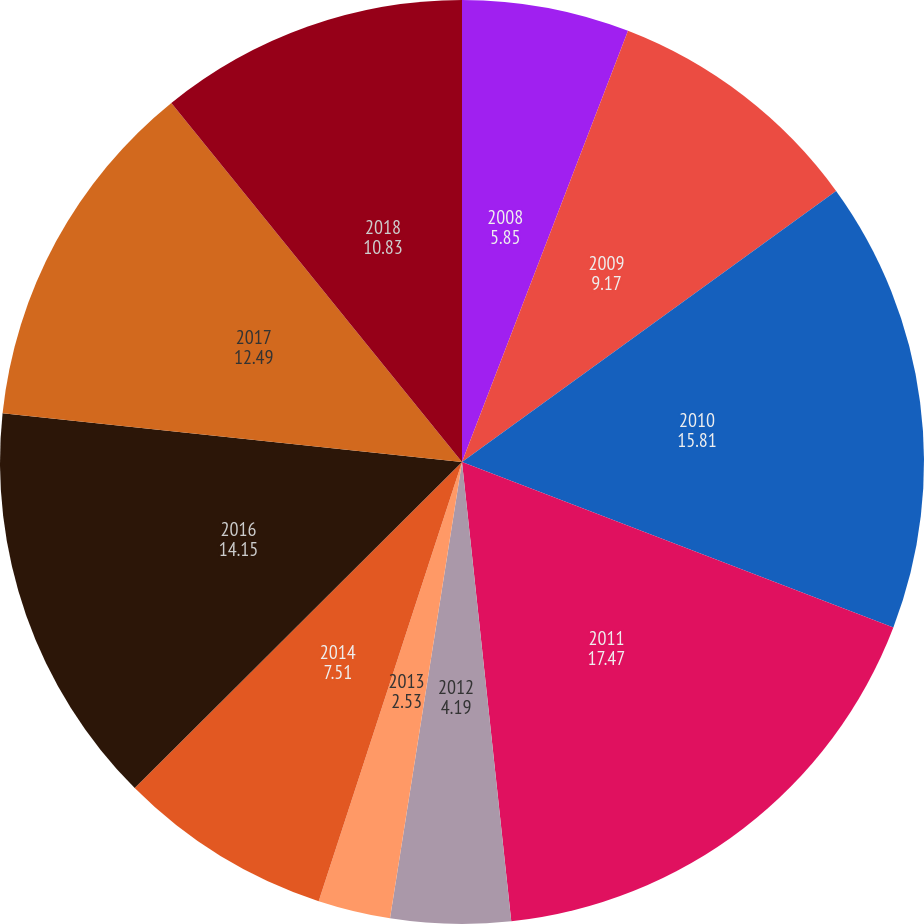<chart> <loc_0><loc_0><loc_500><loc_500><pie_chart><fcel>2008<fcel>2009<fcel>2010<fcel>2011<fcel>2012<fcel>2013<fcel>2014<fcel>2016<fcel>2017<fcel>2018<nl><fcel>5.85%<fcel>9.17%<fcel>15.81%<fcel>17.47%<fcel>4.19%<fcel>2.53%<fcel>7.51%<fcel>14.15%<fcel>12.49%<fcel>10.83%<nl></chart> 